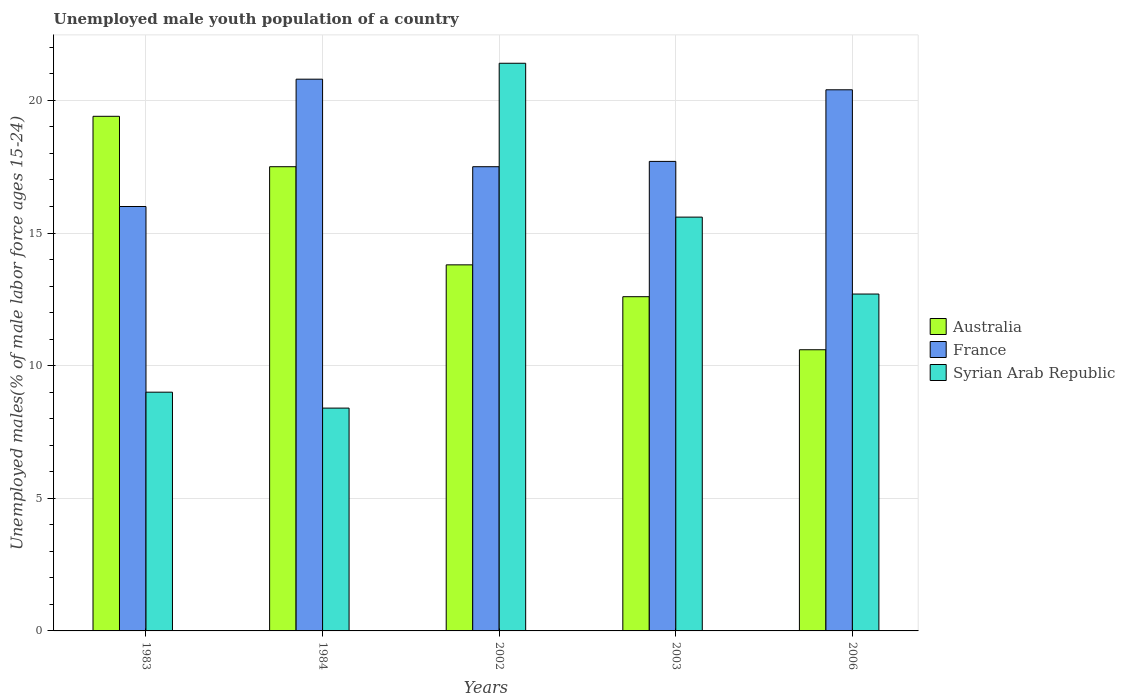Are the number of bars on each tick of the X-axis equal?
Offer a terse response. Yes. In how many cases, is the number of bars for a given year not equal to the number of legend labels?
Your answer should be compact. 0. What is the percentage of unemployed male youth population in Syrian Arab Republic in 1984?
Keep it short and to the point. 8.4. Across all years, what is the maximum percentage of unemployed male youth population in Syrian Arab Republic?
Your answer should be very brief. 21.4. Across all years, what is the minimum percentage of unemployed male youth population in Syrian Arab Republic?
Ensure brevity in your answer.  8.4. What is the total percentage of unemployed male youth population in Syrian Arab Republic in the graph?
Provide a succinct answer. 67.1. What is the difference between the percentage of unemployed male youth population in Australia in 1983 and that in 2002?
Make the answer very short. 5.6. What is the difference between the percentage of unemployed male youth population in Australia in 2002 and the percentage of unemployed male youth population in France in 1983?
Your answer should be compact. -2.2. What is the average percentage of unemployed male youth population in France per year?
Ensure brevity in your answer.  18.48. In the year 2006, what is the difference between the percentage of unemployed male youth population in Syrian Arab Republic and percentage of unemployed male youth population in Australia?
Your response must be concise. 2.1. What is the ratio of the percentage of unemployed male youth population in Australia in 1984 to that in 2006?
Your answer should be compact. 1.65. Is the percentage of unemployed male youth population in Syrian Arab Republic in 1984 less than that in 2002?
Give a very brief answer. Yes. Is the difference between the percentage of unemployed male youth population in Syrian Arab Republic in 1984 and 2003 greater than the difference between the percentage of unemployed male youth population in Australia in 1984 and 2003?
Your answer should be very brief. No. What is the difference between the highest and the second highest percentage of unemployed male youth population in Syrian Arab Republic?
Offer a terse response. 5.8. What is the difference between the highest and the lowest percentage of unemployed male youth population in Australia?
Make the answer very short. 8.8. Is the sum of the percentage of unemployed male youth population in Australia in 2003 and 2006 greater than the maximum percentage of unemployed male youth population in France across all years?
Provide a short and direct response. Yes. What does the 3rd bar from the left in 1983 represents?
Your answer should be very brief. Syrian Arab Republic. What does the 2nd bar from the right in 2002 represents?
Provide a short and direct response. France. Is it the case that in every year, the sum of the percentage of unemployed male youth population in Australia and percentage of unemployed male youth population in France is greater than the percentage of unemployed male youth population in Syrian Arab Republic?
Provide a short and direct response. Yes. How many bars are there?
Your answer should be compact. 15. Are all the bars in the graph horizontal?
Offer a terse response. No. How many years are there in the graph?
Your answer should be compact. 5. What is the difference between two consecutive major ticks on the Y-axis?
Ensure brevity in your answer.  5. Are the values on the major ticks of Y-axis written in scientific E-notation?
Keep it short and to the point. No. Does the graph contain any zero values?
Provide a short and direct response. No. Where does the legend appear in the graph?
Your answer should be very brief. Center right. How are the legend labels stacked?
Make the answer very short. Vertical. What is the title of the graph?
Ensure brevity in your answer.  Unemployed male youth population of a country. Does "Korea (Democratic)" appear as one of the legend labels in the graph?
Offer a very short reply. No. What is the label or title of the X-axis?
Keep it short and to the point. Years. What is the label or title of the Y-axis?
Your answer should be compact. Unemployed males(% of male labor force ages 15-24). What is the Unemployed males(% of male labor force ages 15-24) of Australia in 1983?
Your response must be concise. 19.4. What is the Unemployed males(% of male labor force ages 15-24) in France in 1983?
Provide a succinct answer. 16. What is the Unemployed males(% of male labor force ages 15-24) of France in 1984?
Ensure brevity in your answer.  20.8. What is the Unemployed males(% of male labor force ages 15-24) in Syrian Arab Republic in 1984?
Offer a terse response. 8.4. What is the Unemployed males(% of male labor force ages 15-24) of Australia in 2002?
Provide a succinct answer. 13.8. What is the Unemployed males(% of male labor force ages 15-24) in France in 2002?
Your answer should be compact. 17.5. What is the Unemployed males(% of male labor force ages 15-24) in Syrian Arab Republic in 2002?
Your answer should be compact. 21.4. What is the Unemployed males(% of male labor force ages 15-24) of Australia in 2003?
Your answer should be very brief. 12.6. What is the Unemployed males(% of male labor force ages 15-24) in France in 2003?
Offer a terse response. 17.7. What is the Unemployed males(% of male labor force ages 15-24) of Syrian Arab Republic in 2003?
Offer a terse response. 15.6. What is the Unemployed males(% of male labor force ages 15-24) of Australia in 2006?
Make the answer very short. 10.6. What is the Unemployed males(% of male labor force ages 15-24) in France in 2006?
Make the answer very short. 20.4. What is the Unemployed males(% of male labor force ages 15-24) of Syrian Arab Republic in 2006?
Give a very brief answer. 12.7. Across all years, what is the maximum Unemployed males(% of male labor force ages 15-24) in Australia?
Give a very brief answer. 19.4. Across all years, what is the maximum Unemployed males(% of male labor force ages 15-24) in France?
Ensure brevity in your answer.  20.8. Across all years, what is the maximum Unemployed males(% of male labor force ages 15-24) of Syrian Arab Republic?
Your answer should be compact. 21.4. Across all years, what is the minimum Unemployed males(% of male labor force ages 15-24) in Australia?
Offer a terse response. 10.6. Across all years, what is the minimum Unemployed males(% of male labor force ages 15-24) in France?
Keep it short and to the point. 16. Across all years, what is the minimum Unemployed males(% of male labor force ages 15-24) of Syrian Arab Republic?
Offer a terse response. 8.4. What is the total Unemployed males(% of male labor force ages 15-24) of Australia in the graph?
Your response must be concise. 73.9. What is the total Unemployed males(% of male labor force ages 15-24) of France in the graph?
Your response must be concise. 92.4. What is the total Unemployed males(% of male labor force ages 15-24) of Syrian Arab Republic in the graph?
Make the answer very short. 67.1. What is the difference between the Unemployed males(% of male labor force ages 15-24) of France in 1983 and that in 1984?
Provide a succinct answer. -4.8. What is the difference between the Unemployed males(% of male labor force ages 15-24) in Australia in 1983 and that in 2002?
Give a very brief answer. 5.6. What is the difference between the Unemployed males(% of male labor force ages 15-24) of Australia in 1983 and that in 2003?
Provide a short and direct response. 6.8. What is the difference between the Unemployed males(% of male labor force ages 15-24) in Syrian Arab Republic in 1983 and that in 2003?
Provide a short and direct response. -6.6. What is the difference between the Unemployed males(% of male labor force ages 15-24) of Australia in 1983 and that in 2006?
Give a very brief answer. 8.8. What is the difference between the Unemployed males(% of male labor force ages 15-24) of France in 1984 and that in 2002?
Your response must be concise. 3.3. What is the difference between the Unemployed males(% of male labor force ages 15-24) of Syrian Arab Republic in 1984 and that in 2003?
Offer a terse response. -7.2. What is the difference between the Unemployed males(% of male labor force ages 15-24) of France in 2002 and that in 2003?
Keep it short and to the point. -0.2. What is the difference between the Unemployed males(% of male labor force ages 15-24) in France in 2003 and that in 2006?
Your answer should be compact. -2.7. What is the difference between the Unemployed males(% of male labor force ages 15-24) of Australia in 1983 and the Unemployed males(% of male labor force ages 15-24) of France in 2002?
Offer a terse response. 1.9. What is the difference between the Unemployed males(% of male labor force ages 15-24) of Australia in 1983 and the Unemployed males(% of male labor force ages 15-24) of Syrian Arab Republic in 2002?
Keep it short and to the point. -2. What is the difference between the Unemployed males(% of male labor force ages 15-24) of France in 1983 and the Unemployed males(% of male labor force ages 15-24) of Syrian Arab Republic in 2002?
Ensure brevity in your answer.  -5.4. What is the difference between the Unemployed males(% of male labor force ages 15-24) in Australia in 1983 and the Unemployed males(% of male labor force ages 15-24) in Syrian Arab Republic in 2003?
Your answer should be compact. 3.8. What is the difference between the Unemployed males(% of male labor force ages 15-24) of Australia in 1983 and the Unemployed males(% of male labor force ages 15-24) of France in 2006?
Offer a very short reply. -1. What is the difference between the Unemployed males(% of male labor force ages 15-24) of Australia in 1983 and the Unemployed males(% of male labor force ages 15-24) of Syrian Arab Republic in 2006?
Your answer should be compact. 6.7. What is the difference between the Unemployed males(% of male labor force ages 15-24) in France in 1983 and the Unemployed males(% of male labor force ages 15-24) in Syrian Arab Republic in 2006?
Provide a succinct answer. 3.3. What is the difference between the Unemployed males(% of male labor force ages 15-24) in Australia in 1984 and the Unemployed males(% of male labor force ages 15-24) in France in 2002?
Make the answer very short. 0. What is the difference between the Unemployed males(% of male labor force ages 15-24) in Australia in 1984 and the Unemployed males(% of male labor force ages 15-24) in Syrian Arab Republic in 2002?
Provide a succinct answer. -3.9. What is the difference between the Unemployed males(% of male labor force ages 15-24) in Australia in 1984 and the Unemployed males(% of male labor force ages 15-24) in Syrian Arab Republic in 2003?
Make the answer very short. 1.9. What is the difference between the Unemployed males(% of male labor force ages 15-24) in Australia in 1984 and the Unemployed males(% of male labor force ages 15-24) in France in 2006?
Provide a succinct answer. -2.9. What is the difference between the Unemployed males(% of male labor force ages 15-24) in Australia in 1984 and the Unemployed males(% of male labor force ages 15-24) in Syrian Arab Republic in 2006?
Provide a succinct answer. 4.8. What is the difference between the Unemployed males(% of male labor force ages 15-24) in Australia in 2002 and the Unemployed males(% of male labor force ages 15-24) in France in 2003?
Provide a short and direct response. -3.9. What is the difference between the Unemployed males(% of male labor force ages 15-24) in Australia in 2002 and the Unemployed males(% of male labor force ages 15-24) in France in 2006?
Your answer should be very brief. -6.6. What is the difference between the Unemployed males(% of male labor force ages 15-24) of Australia in 2002 and the Unemployed males(% of male labor force ages 15-24) of Syrian Arab Republic in 2006?
Keep it short and to the point. 1.1. What is the difference between the Unemployed males(% of male labor force ages 15-24) in France in 2002 and the Unemployed males(% of male labor force ages 15-24) in Syrian Arab Republic in 2006?
Offer a very short reply. 4.8. What is the difference between the Unemployed males(% of male labor force ages 15-24) in Australia in 2003 and the Unemployed males(% of male labor force ages 15-24) in Syrian Arab Republic in 2006?
Make the answer very short. -0.1. What is the average Unemployed males(% of male labor force ages 15-24) of Australia per year?
Offer a very short reply. 14.78. What is the average Unemployed males(% of male labor force ages 15-24) of France per year?
Give a very brief answer. 18.48. What is the average Unemployed males(% of male labor force ages 15-24) of Syrian Arab Republic per year?
Make the answer very short. 13.42. In the year 1983, what is the difference between the Unemployed males(% of male labor force ages 15-24) of Australia and Unemployed males(% of male labor force ages 15-24) of Syrian Arab Republic?
Keep it short and to the point. 10.4. In the year 1983, what is the difference between the Unemployed males(% of male labor force ages 15-24) of France and Unemployed males(% of male labor force ages 15-24) of Syrian Arab Republic?
Your answer should be compact. 7. In the year 1984, what is the difference between the Unemployed males(% of male labor force ages 15-24) of Australia and Unemployed males(% of male labor force ages 15-24) of France?
Offer a terse response. -3.3. In the year 1984, what is the difference between the Unemployed males(% of male labor force ages 15-24) of France and Unemployed males(% of male labor force ages 15-24) of Syrian Arab Republic?
Offer a very short reply. 12.4. In the year 2002, what is the difference between the Unemployed males(% of male labor force ages 15-24) of Australia and Unemployed males(% of male labor force ages 15-24) of France?
Keep it short and to the point. -3.7. In the year 2002, what is the difference between the Unemployed males(% of male labor force ages 15-24) of Australia and Unemployed males(% of male labor force ages 15-24) of Syrian Arab Republic?
Give a very brief answer. -7.6. In the year 2002, what is the difference between the Unemployed males(% of male labor force ages 15-24) in France and Unemployed males(% of male labor force ages 15-24) in Syrian Arab Republic?
Give a very brief answer. -3.9. In the year 2003, what is the difference between the Unemployed males(% of male labor force ages 15-24) in France and Unemployed males(% of male labor force ages 15-24) in Syrian Arab Republic?
Make the answer very short. 2.1. In the year 2006, what is the difference between the Unemployed males(% of male labor force ages 15-24) of Australia and Unemployed males(% of male labor force ages 15-24) of France?
Provide a succinct answer. -9.8. In the year 2006, what is the difference between the Unemployed males(% of male labor force ages 15-24) in Australia and Unemployed males(% of male labor force ages 15-24) in Syrian Arab Republic?
Offer a very short reply. -2.1. What is the ratio of the Unemployed males(% of male labor force ages 15-24) of Australia in 1983 to that in 1984?
Keep it short and to the point. 1.11. What is the ratio of the Unemployed males(% of male labor force ages 15-24) in France in 1983 to that in 1984?
Offer a very short reply. 0.77. What is the ratio of the Unemployed males(% of male labor force ages 15-24) in Syrian Arab Republic in 1983 to that in 1984?
Give a very brief answer. 1.07. What is the ratio of the Unemployed males(% of male labor force ages 15-24) in Australia in 1983 to that in 2002?
Offer a terse response. 1.41. What is the ratio of the Unemployed males(% of male labor force ages 15-24) of France in 1983 to that in 2002?
Your answer should be very brief. 0.91. What is the ratio of the Unemployed males(% of male labor force ages 15-24) of Syrian Arab Republic in 1983 to that in 2002?
Ensure brevity in your answer.  0.42. What is the ratio of the Unemployed males(% of male labor force ages 15-24) of Australia in 1983 to that in 2003?
Keep it short and to the point. 1.54. What is the ratio of the Unemployed males(% of male labor force ages 15-24) in France in 1983 to that in 2003?
Your answer should be very brief. 0.9. What is the ratio of the Unemployed males(% of male labor force ages 15-24) of Syrian Arab Republic in 1983 to that in 2003?
Make the answer very short. 0.58. What is the ratio of the Unemployed males(% of male labor force ages 15-24) of Australia in 1983 to that in 2006?
Your answer should be compact. 1.83. What is the ratio of the Unemployed males(% of male labor force ages 15-24) of France in 1983 to that in 2006?
Give a very brief answer. 0.78. What is the ratio of the Unemployed males(% of male labor force ages 15-24) of Syrian Arab Republic in 1983 to that in 2006?
Your answer should be compact. 0.71. What is the ratio of the Unemployed males(% of male labor force ages 15-24) of Australia in 1984 to that in 2002?
Offer a very short reply. 1.27. What is the ratio of the Unemployed males(% of male labor force ages 15-24) of France in 1984 to that in 2002?
Make the answer very short. 1.19. What is the ratio of the Unemployed males(% of male labor force ages 15-24) of Syrian Arab Republic in 1984 to that in 2002?
Offer a terse response. 0.39. What is the ratio of the Unemployed males(% of male labor force ages 15-24) of Australia in 1984 to that in 2003?
Ensure brevity in your answer.  1.39. What is the ratio of the Unemployed males(% of male labor force ages 15-24) in France in 1984 to that in 2003?
Your answer should be compact. 1.18. What is the ratio of the Unemployed males(% of male labor force ages 15-24) in Syrian Arab Republic in 1984 to that in 2003?
Provide a short and direct response. 0.54. What is the ratio of the Unemployed males(% of male labor force ages 15-24) of Australia in 1984 to that in 2006?
Keep it short and to the point. 1.65. What is the ratio of the Unemployed males(% of male labor force ages 15-24) in France in 1984 to that in 2006?
Make the answer very short. 1.02. What is the ratio of the Unemployed males(% of male labor force ages 15-24) in Syrian Arab Republic in 1984 to that in 2006?
Keep it short and to the point. 0.66. What is the ratio of the Unemployed males(% of male labor force ages 15-24) of Australia in 2002 to that in 2003?
Make the answer very short. 1.1. What is the ratio of the Unemployed males(% of male labor force ages 15-24) in France in 2002 to that in 2003?
Provide a succinct answer. 0.99. What is the ratio of the Unemployed males(% of male labor force ages 15-24) of Syrian Arab Republic in 2002 to that in 2003?
Ensure brevity in your answer.  1.37. What is the ratio of the Unemployed males(% of male labor force ages 15-24) in Australia in 2002 to that in 2006?
Your answer should be compact. 1.3. What is the ratio of the Unemployed males(% of male labor force ages 15-24) of France in 2002 to that in 2006?
Your answer should be compact. 0.86. What is the ratio of the Unemployed males(% of male labor force ages 15-24) in Syrian Arab Republic in 2002 to that in 2006?
Provide a succinct answer. 1.69. What is the ratio of the Unemployed males(% of male labor force ages 15-24) of Australia in 2003 to that in 2006?
Provide a succinct answer. 1.19. What is the ratio of the Unemployed males(% of male labor force ages 15-24) in France in 2003 to that in 2006?
Provide a short and direct response. 0.87. What is the ratio of the Unemployed males(% of male labor force ages 15-24) of Syrian Arab Republic in 2003 to that in 2006?
Make the answer very short. 1.23. What is the difference between the highest and the second highest Unemployed males(% of male labor force ages 15-24) in Australia?
Keep it short and to the point. 1.9. What is the difference between the highest and the lowest Unemployed males(% of male labor force ages 15-24) in France?
Make the answer very short. 4.8. 